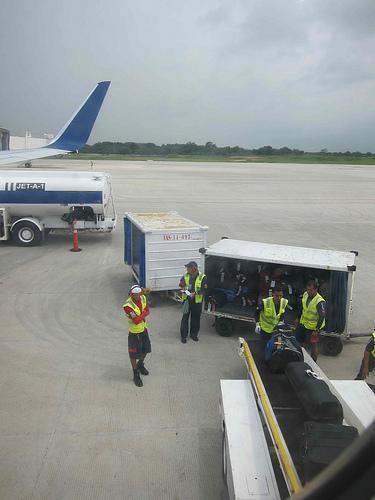How many planes are there?
Give a very brief answer. 1. 